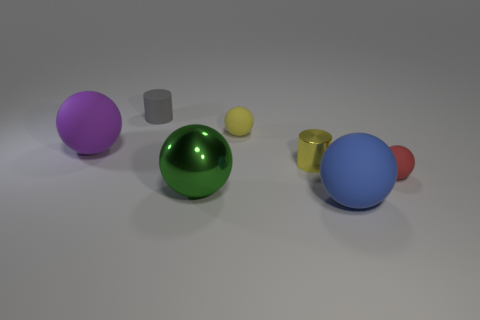Add 2 blue matte things. How many objects exist? 9 Subtract all small yellow matte spheres. How many spheres are left? 4 Subtract all gray cylinders. How many cylinders are left? 1 Subtract 0 gray blocks. How many objects are left? 7 Subtract all balls. How many objects are left? 2 Subtract 3 spheres. How many spheres are left? 2 Subtract all gray cylinders. Subtract all red cubes. How many cylinders are left? 1 Subtract all red cylinders. How many blue balls are left? 1 Subtract all big yellow matte objects. Subtract all gray cylinders. How many objects are left? 6 Add 4 large green balls. How many large green balls are left? 5 